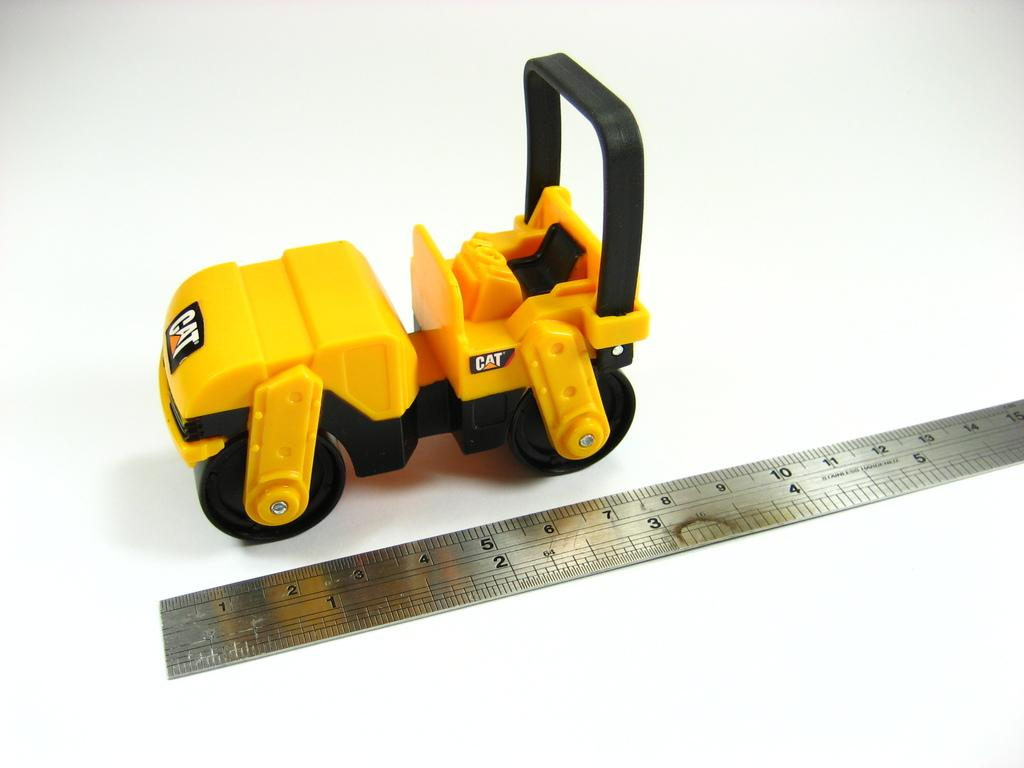What type of toy is present in the image? There is a toy vehicle in the image. What other object can be seen in the image? There is a scale visible in the image. What color is the surface on which the objects are placed? The white surface is visible in the image. What type of harmony can be heard in the background of the image? There is no audible harmony present in the image, as it is a still image. Where is the prison located in the image? There is no prison present in the image. 